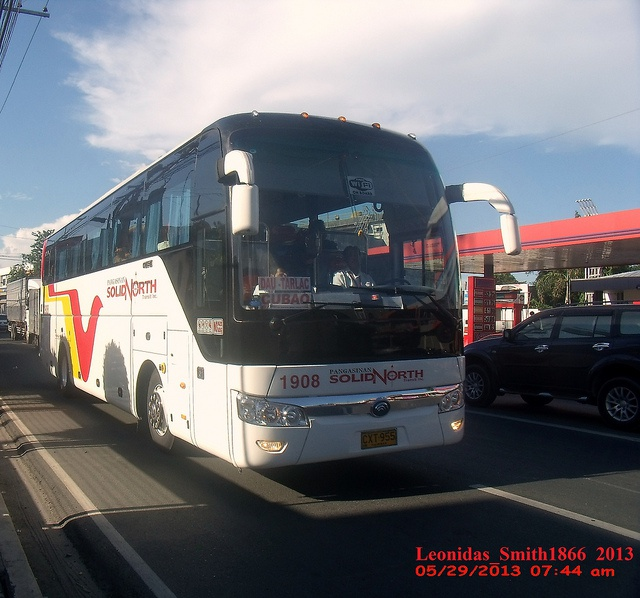Describe the objects in this image and their specific colors. I can see bus in darkblue, gray, black, and ivory tones, car in darkblue, black, and gray tones, people in black and darkblue tones, people in darkblue, black, and gray tones, and people in darkblue, black, and gray tones in this image. 